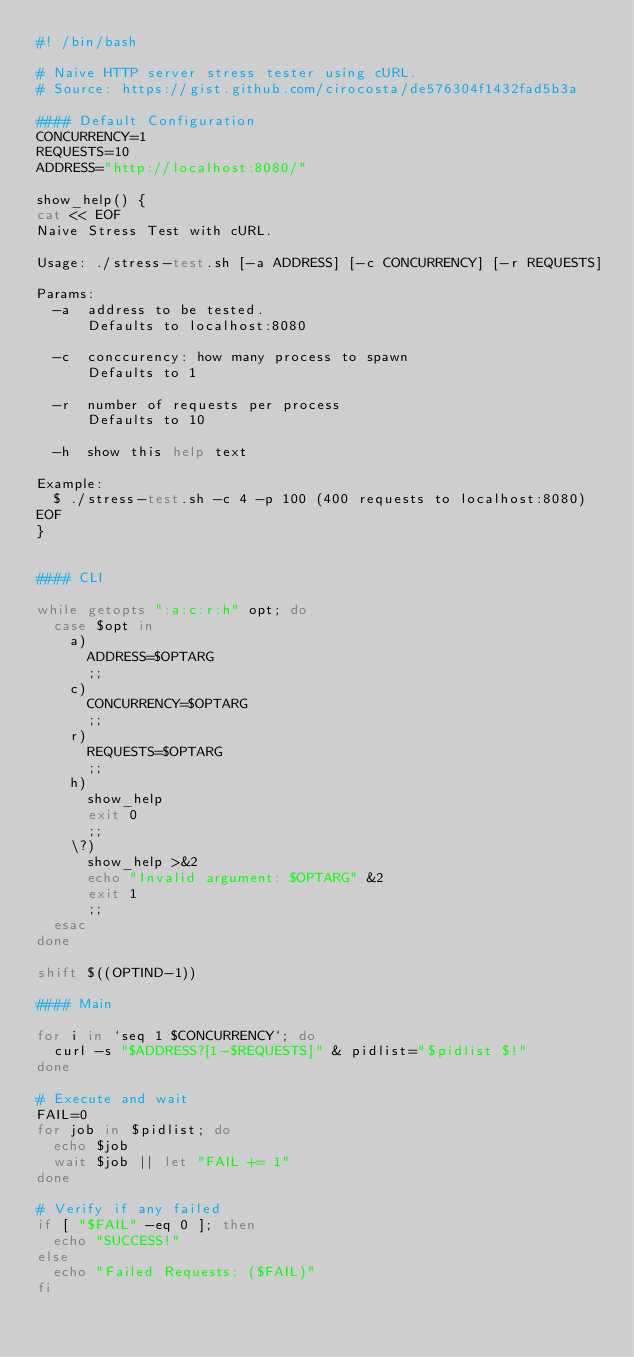<code> <loc_0><loc_0><loc_500><loc_500><_Bash_>#! /bin/bash

# Naive HTTP server stress tester using cURL.
# Source: https://gist.github.com/cirocosta/de576304f1432fad5b3a

#### Default Configuration
CONCURRENCY=1
REQUESTS=10
ADDRESS="http://localhost:8080/"

show_help() {
cat << EOF
Naive Stress Test with cURL.

Usage: ./stress-test.sh [-a ADDRESS] [-c CONCURRENCY] [-r REQUESTS]

Params:
  -a  address to be tested.
      Defaults to localhost:8080

  -c  conccurency: how many process to spawn
      Defaults to 1

  -r  number of requests per process
      Defaults to 10

  -h  show this help text

Example:
  $ ./stress-test.sh -c 4 -p 100 (400 requests to localhost:8080)
EOF
}


#### CLI

while getopts ":a:c:r:h" opt; do
  case $opt in
    a)
      ADDRESS=$OPTARG
      ;;
    c)
      CONCURRENCY=$OPTARG
      ;;
    r)
      REQUESTS=$OPTARG
      ;;
    h)
      show_help
      exit 0
      ;;
    \?)
      show_help >&2
      echo "Invalid argument: $OPTARG" &2
      exit 1
      ;;
  esac
done

shift $((OPTIND-1))

#### Main

for i in `seq 1 $CONCURRENCY`; do
  curl -s "$ADDRESS?[1-$REQUESTS]" & pidlist="$pidlist $!"
done

# Execute and wait
FAIL=0
for job in $pidlist; do
  echo $job
  wait $job || let "FAIL += 1"
done

# Verify if any failed
if [ "$FAIL" -eq 0 ]; then
  echo "SUCCESS!"
else
  echo "Failed Requests: ($FAIL)"
fi
</code> 